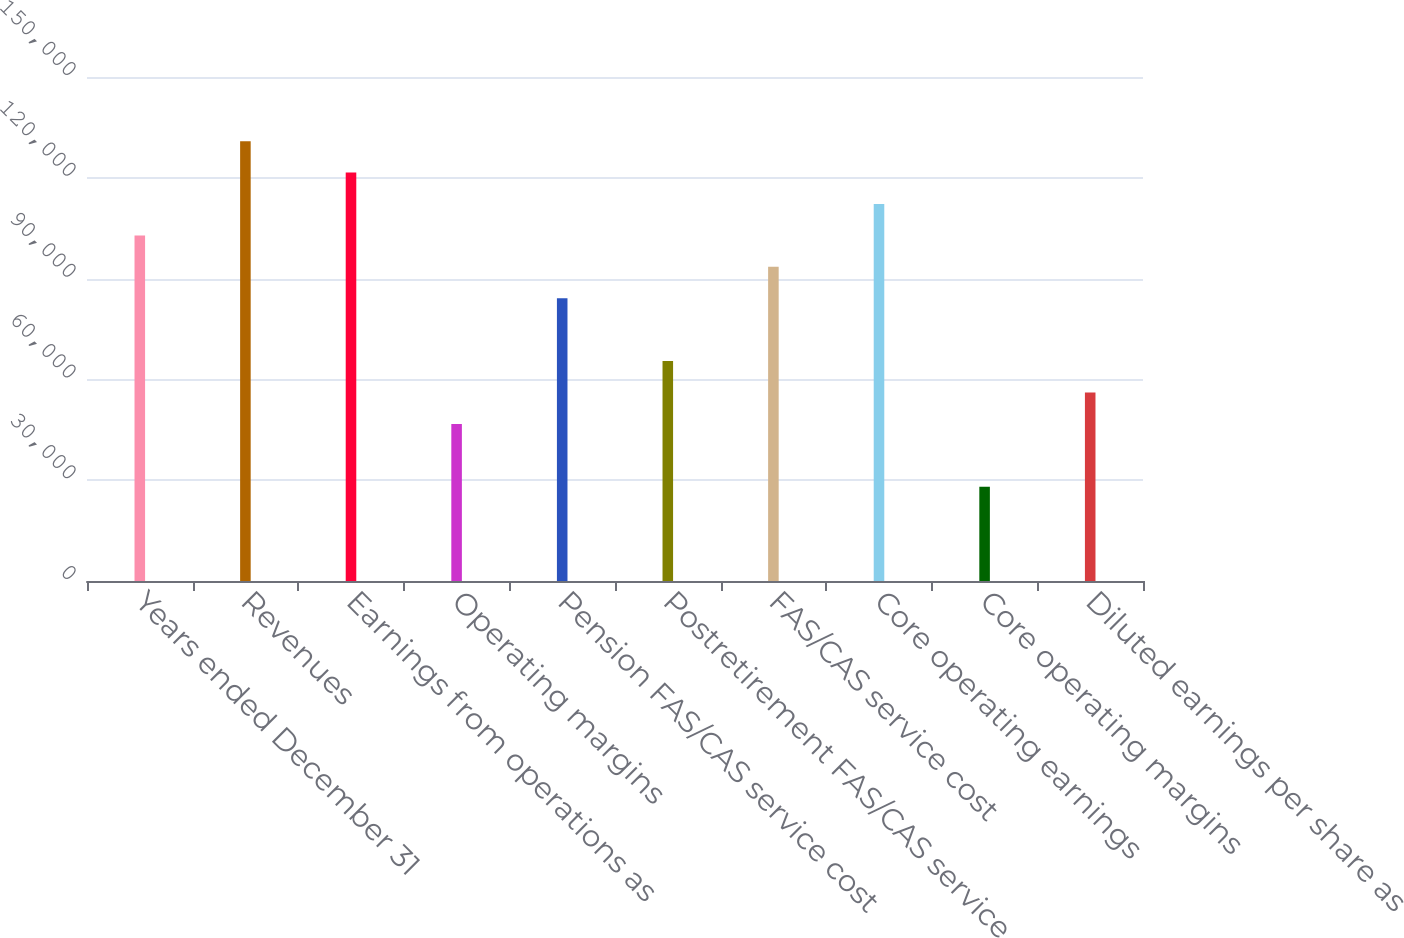Convert chart. <chart><loc_0><loc_0><loc_500><loc_500><bar_chart><fcel>Years ended December 31<fcel>Revenues<fcel>Earnings from operations as<fcel>Operating margins<fcel>Pension FAS/CAS service cost<fcel>Postretirement FAS/CAS service<fcel>FAS/CAS service cost<fcel>Core operating earnings<fcel>Core operating margins<fcel>Diluted earnings per share as<nl><fcel>102846<fcel>130894<fcel>121545<fcel>46748.1<fcel>84146.4<fcel>65447.3<fcel>93496<fcel>112195<fcel>28049<fcel>56097.7<nl></chart> 